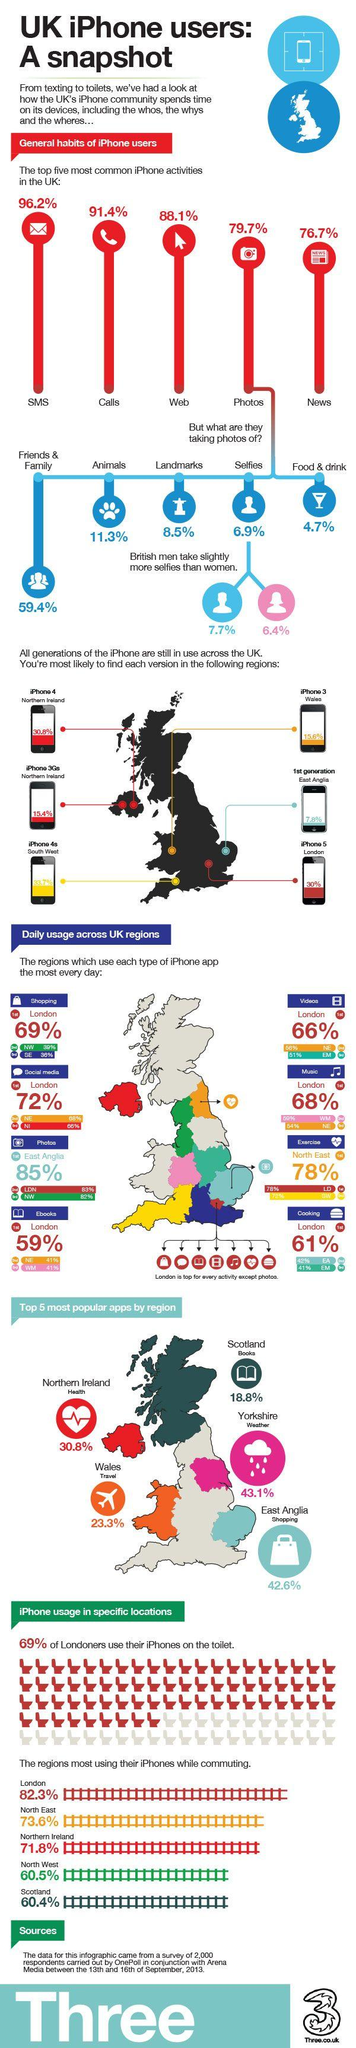Give some essential details in this illustration. According to a survey conducted in 2013, London is the country in the UK that still uses iPhone 5 series the most. A survey conducted in 2013 in North West London found that 39% of iPhone users used iPhone apps for shopping. In a survey conducted in 2013 in the UK, it was found that a significant percentage of iPhone users spend a significant amount of their time taking photos. Specifically, 79.7% of iPhone users were found to spend their time taking photos. According to a survey conducted in the UK in 2013, only 7.7% of selfies taken on iPhones were taken by men. According to a survey conducted in 2013, the majority of iPhone users in the UK spend their time on SMS activities. 